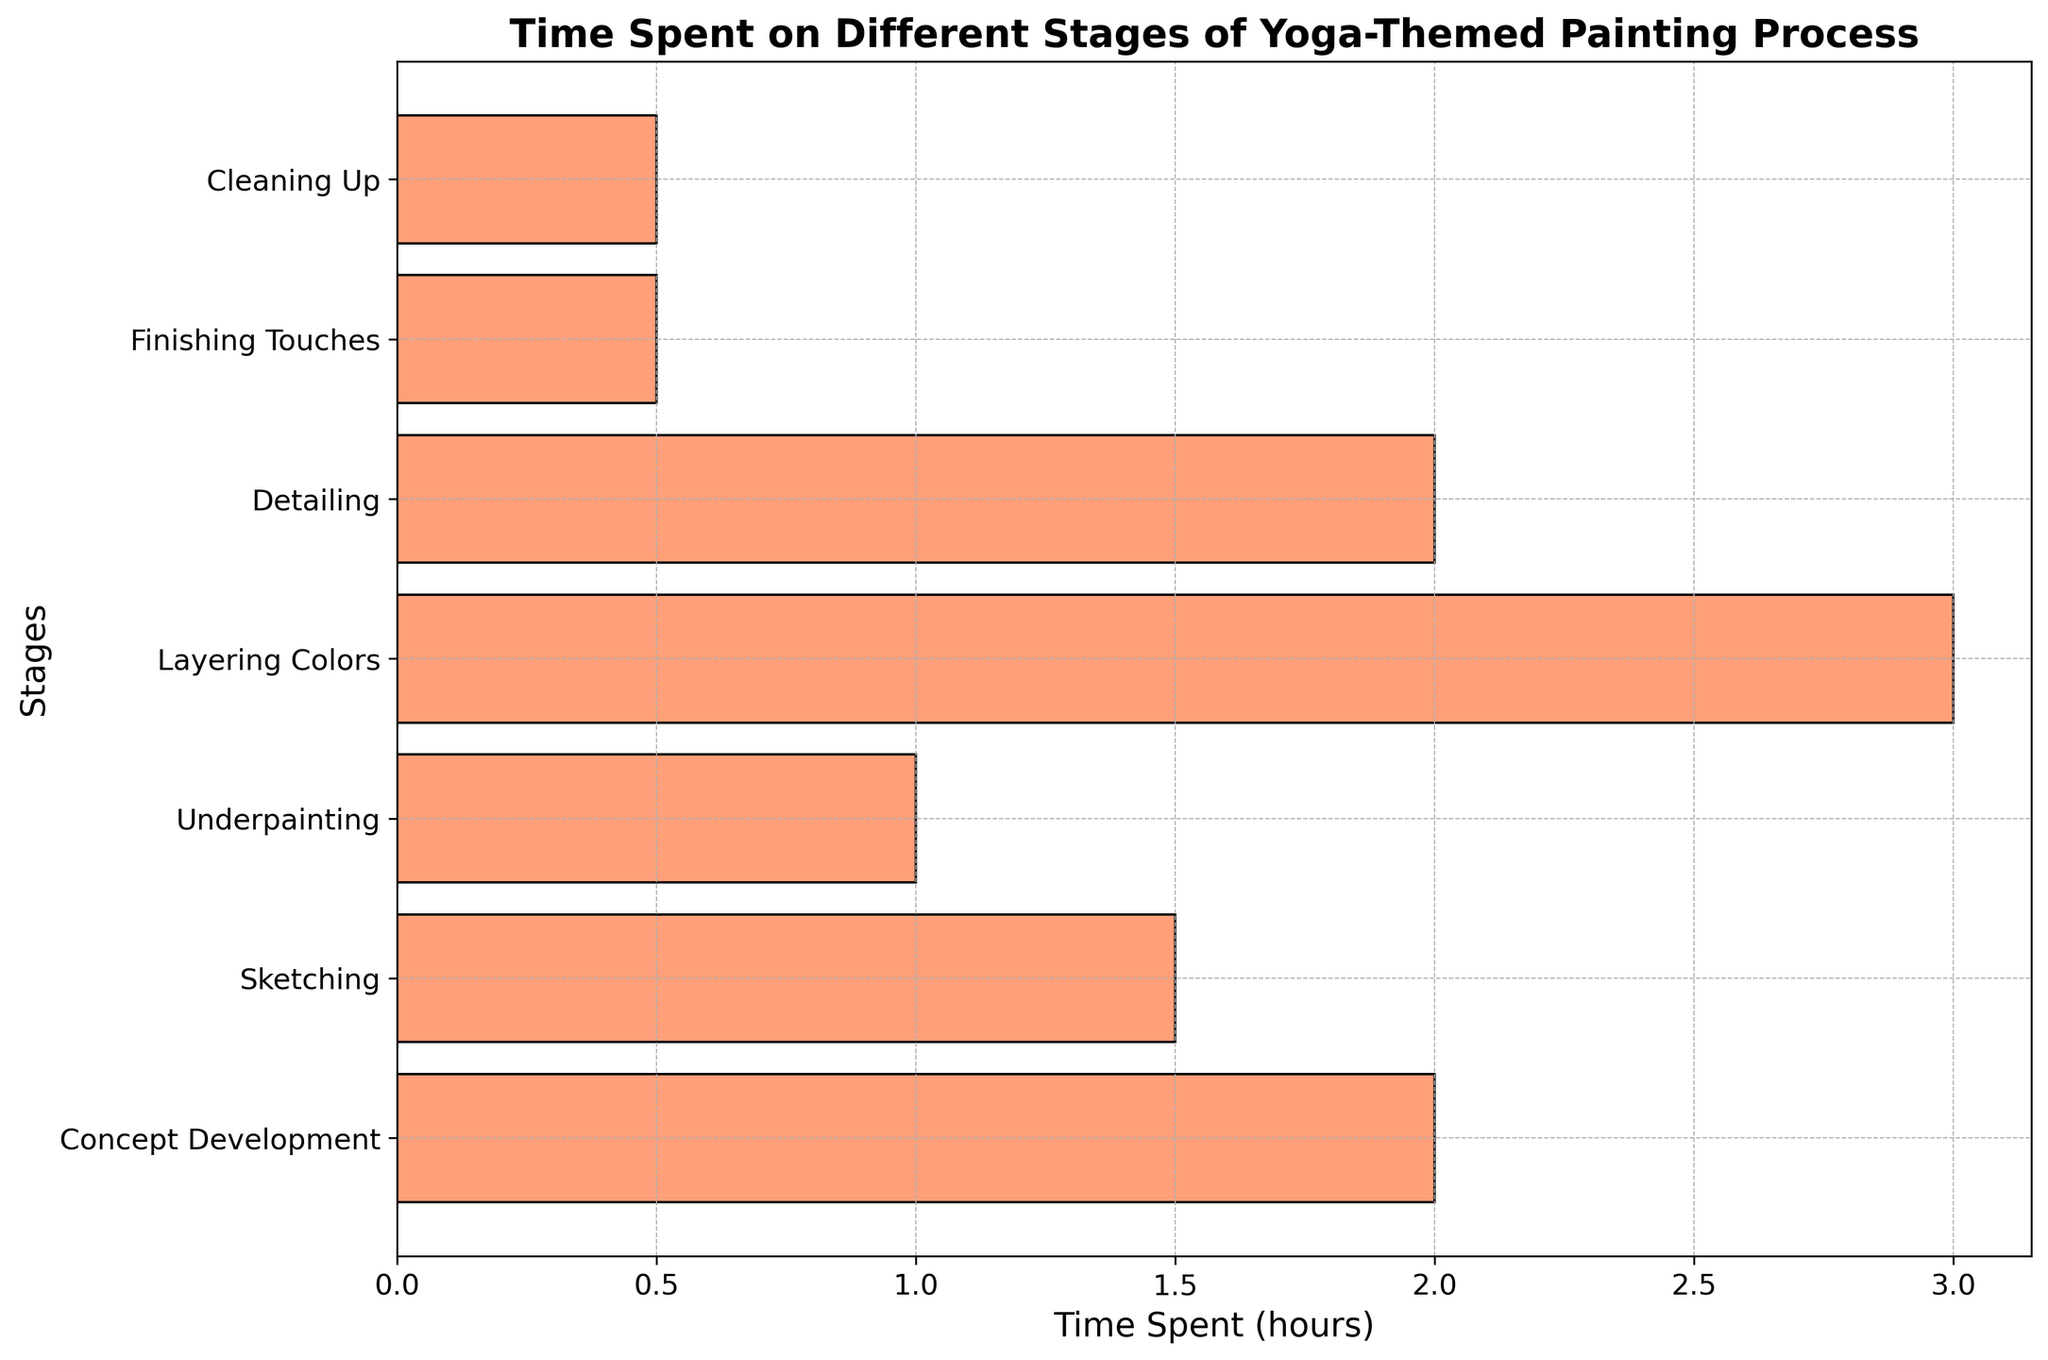What is the stage with the highest time spent? Find the bar that extends the furthest to the right, representing the highest value. The stage corresponding to the bar with the highest value is 'Layering Colors' with 3 hours.
Answer: Layering Colors Which stages have equal time spent? Look for bars with the same length. Both 'Finishing Touches' and 'Cleaning Up' have bars of the same length, indicating they both have 0.5 hours of time spent.
Answer: Finishing Touches and Cleaning Up What is the total time spent on the painting process? Add the time spent on all stages: 2 (Concept Development) + 1.5 (Sketching) + 1 (Underpainting) + 3 (Layering Colors) + 2 (Detailing) + 0.5 (Finishing Touches) + 0.5 (Cleaning Up) = 10.5 hours.
Answer: 10.5 hours Which stage took longer, Concept Development or Detailing? Compare the lengths of the bars. Concept Development (2 hours) is equal to Detailing (2 hours).
Answer: Equal How much more time is spent on Layering Colors compared to Sketching? Subtract the time spent on Sketching from Layering Colors: 3 (Layering Colors) - 1.5 (Sketching) = 1.5 hours.
Answer: 1.5 hours What is the average time spent on all stages? Calculate the total time and then divide by the number of stages: (2 + 1.5 + 1 + 3 + 2 + 0.5 + 0.5) / 7 = 10.5 / 7 ≈ 1.5 hours.
Answer: 1.5 hours What percentage of the total time is spent on Underpainting? Divide the time spent on Underpainting by the total time and multiply by 100: (1 / 10.5) * 100 ≈ 9.52%.
Answer: 9.52% Arrange the stages in order from least to most time spent. Ordering the stages by the time spent: Finishing Touches (0.5), Cleaning Up (0.5), Underpainting (1), Sketching (1.5), Concept Development (2), Detailing (2), Layering Colors (3).
Answer: Finishing Touches, Cleaning Up, Underpainting, Sketching, Concept Development, Detailing, Layering Colors 